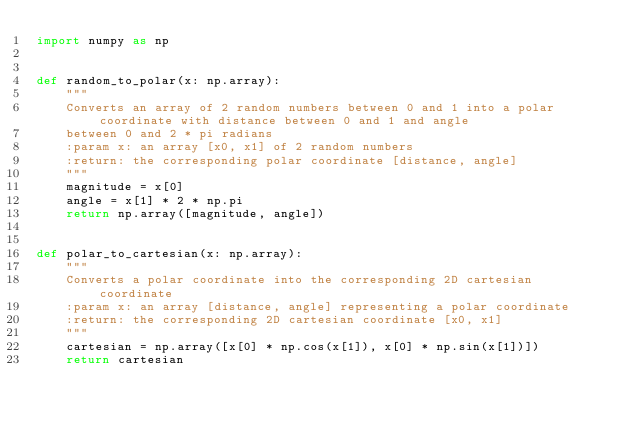Convert code to text. <code><loc_0><loc_0><loc_500><loc_500><_Python_>import numpy as np


def random_to_polar(x: np.array):
    """
    Converts an array of 2 random numbers between 0 and 1 into a polar coordinate with distance between 0 and 1 and angle
    between 0 and 2 * pi radians
    :param x: an array [x0, x1] of 2 random numbers
    :return: the corresponding polar coordinate [distance, angle]
    """
    magnitude = x[0]
    angle = x[1] * 2 * np.pi
    return np.array([magnitude, angle])


def polar_to_cartesian(x: np.array):
    """
    Converts a polar coordinate into the corresponding 2D cartesian coordinate
    :param x: an array [distance, angle] representing a polar coordinate
    :return: the corresponding 2D cartesian coordinate [x0, x1]
    """
    cartesian = np.array([x[0] * np.cos(x[1]), x[0] * np.sin(x[1])])
    return cartesian</code> 